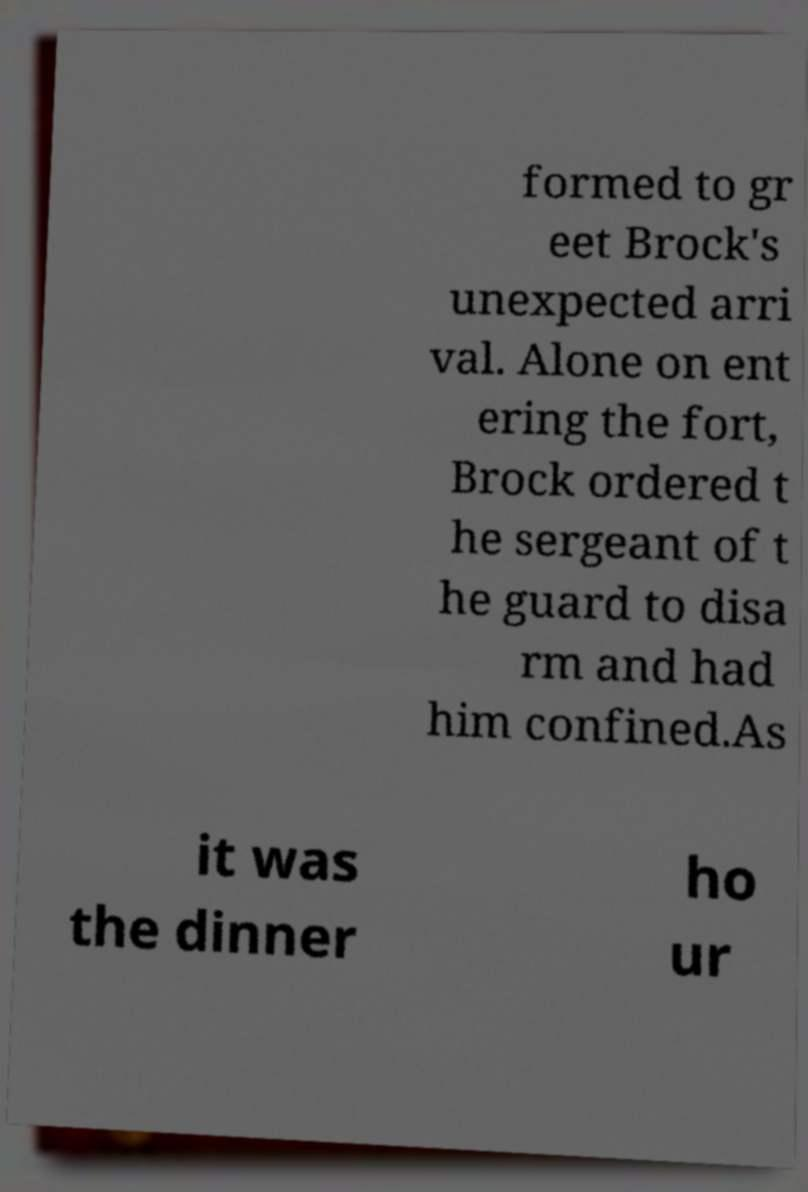Can you accurately transcribe the text from the provided image for me? formed to gr eet Brock's unexpected arri val. Alone on ent ering the fort, Brock ordered t he sergeant of t he guard to disa rm and had him confined.As it was the dinner ho ur 